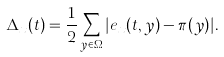<formula> <loc_0><loc_0><loc_500><loc_500>\Delta _ { x } ( t ) = \frac { 1 } { 2 } \sum _ { y \in \Omega } | e _ { x } ( t , y ) - \pi ( y ) | .</formula> 